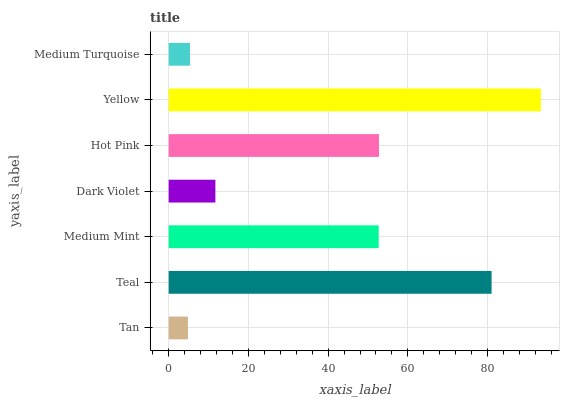Is Tan the minimum?
Answer yes or no. Yes. Is Yellow the maximum?
Answer yes or no. Yes. Is Teal the minimum?
Answer yes or no. No. Is Teal the maximum?
Answer yes or no. No. Is Teal greater than Tan?
Answer yes or no. Yes. Is Tan less than Teal?
Answer yes or no. Yes. Is Tan greater than Teal?
Answer yes or no. No. Is Teal less than Tan?
Answer yes or no. No. Is Medium Mint the high median?
Answer yes or no. Yes. Is Medium Mint the low median?
Answer yes or no. Yes. Is Medium Turquoise the high median?
Answer yes or no. No. Is Yellow the low median?
Answer yes or no. No. 